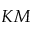Convert formula to latex. <formula><loc_0><loc_0><loc_500><loc_500>K M</formula> 